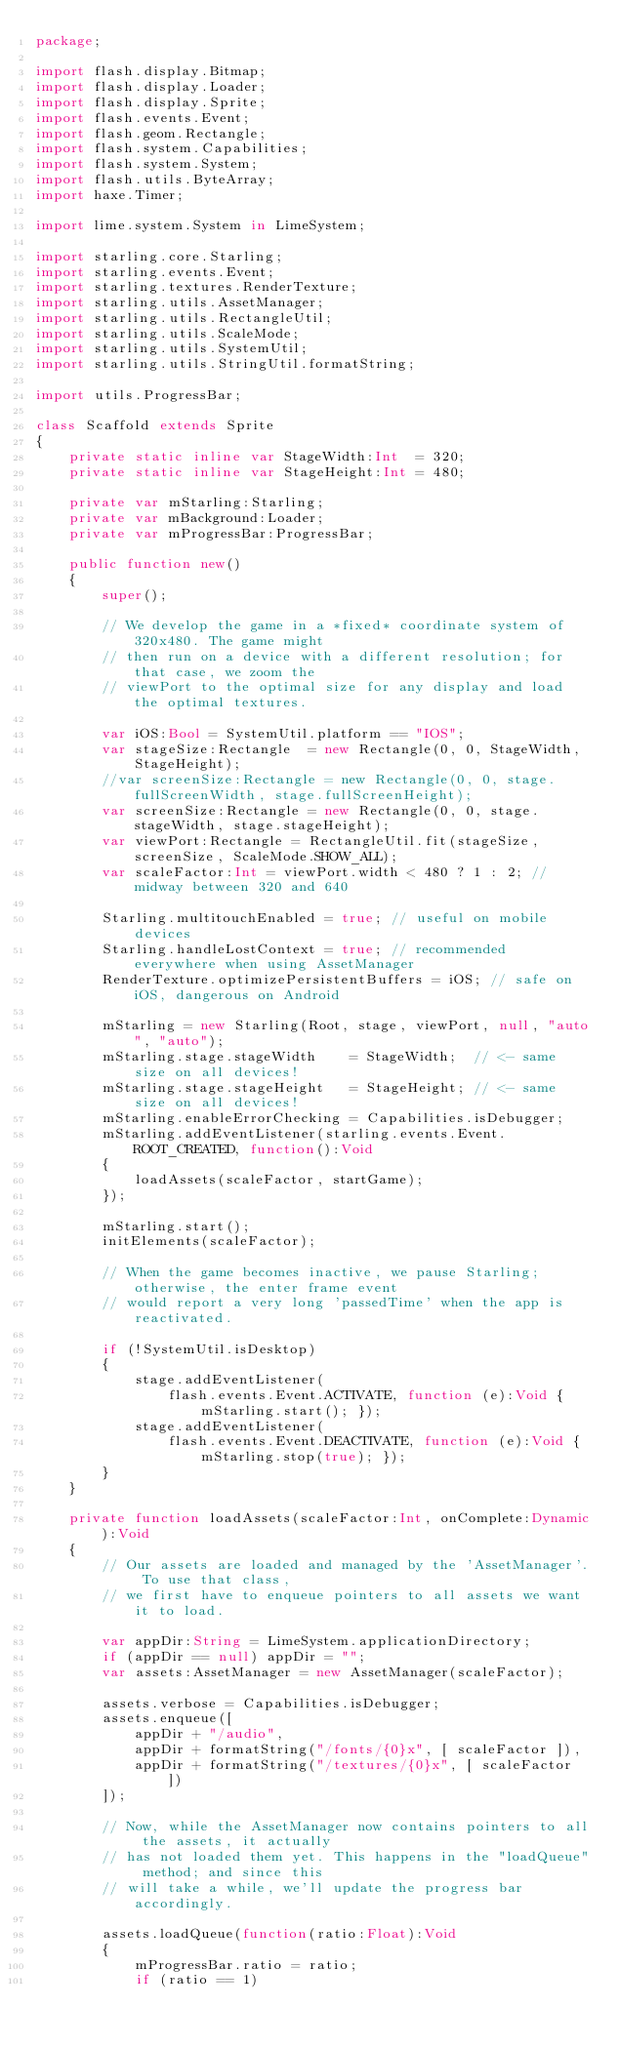Convert code to text. <code><loc_0><loc_0><loc_500><loc_500><_Haxe_>package;

import flash.display.Bitmap;
import flash.display.Loader;
import flash.display.Sprite;
import flash.events.Event;
import flash.geom.Rectangle;
import flash.system.Capabilities;
import flash.system.System;
import flash.utils.ByteArray;
import haxe.Timer;

import lime.system.System in LimeSystem;

import starling.core.Starling;
import starling.events.Event;
import starling.textures.RenderTexture;
import starling.utils.AssetManager;
import starling.utils.RectangleUtil;
import starling.utils.ScaleMode;
import starling.utils.SystemUtil;
import starling.utils.StringUtil.formatString;

import utils.ProgressBar;

class Scaffold extends Sprite
{
    private static inline var StageWidth:Int  = 320;
    private static inline var StageHeight:Int = 480;

    private var mStarling:Starling;
    private var mBackground:Loader;
    private var mProgressBar:ProgressBar;

    public function new()
    {
        super();

        // We develop the game in a *fixed* coordinate system of 320x480. The game might
        // then run on a device with a different resolution; for that case, we zoom the
        // viewPort to the optimal size for any display and load the optimal textures.

        var iOS:Bool = SystemUtil.platform == "IOS";
        var stageSize:Rectangle  = new Rectangle(0, 0, StageWidth, StageHeight);
        //var screenSize:Rectangle = new Rectangle(0, 0, stage.fullScreenWidth, stage.fullScreenHeight);
        var screenSize:Rectangle = new Rectangle(0, 0, stage.stageWidth, stage.stageHeight);
        var viewPort:Rectangle = RectangleUtil.fit(stageSize, screenSize, ScaleMode.SHOW_ALL);
        var scaleFactor:Int = viewPort.width < 480 ? 1 : 2; // midway between 320 and 640

        Starling.multitouchEnabled = true; // useful on mobile devices
        Starling.handleLostContext = true; // recommended everywhere when using AssetManager
        RenderTexture.optimizePersistentBuffers = iOS; // safe on iOS, dangerous on Android

        mStarling = new Starling(Root, stage, viewPort, null, "auto", "auto");
        mStarling.stage.stageWidth    = StageWidth;  // <- same size on all devices!
        mStarling.stage.stageHeight   = StageHeight; // <- same size on all devices!
        mStarling.enableErrorChecking = Capabilities.isDebugger;
        mStarling.addEventListener(starling.events.Event.ROOT_CREATED, function():Void
        {
            loadAssets(scaleFactor, startGame);
        });

        mStarling.start();
        initElements(scaleFactor);

        // When the game becomes inactive, we pause Starling; otherwise, the enter frame event
        // would report a very long 'passedTime' when the app is reactivated.

        if (!SystemUtil.isDesktop)
        {
            stage.addEventListener(
                flash.events.Event.ACTIVATE, function (e):Void { mStarling.start(); });
            stage.addEventListener(
                flash.events.Event.DEACTIVATE, function (e):Void { mStarling.stop(true); });
        }
    }

    private function loadAssets(scaleFactor:Int, onComplete:Dynamic):Void
    {
        // Our assets are loaded and managed by the 'AssetManager'. To use that class,
        // we first have to enqueue pointers to all assets we want it to load.

        var appDir:String = LimeSystem.applicationDirectory;
        if (appDir == null) appDir = "";
        var assets:AssetManager = new AssetManager(scaleFactor);

        assets.verbose = Capabilities.isDebugger;
        assets.enqueue([
            appDir + "/audio",
            appDir + formatString("/fonts/{0}x", [ scaleFactor ]),
            appDir + formatString("/textures/{0}x", [ scaleFactor ])
        ]);

        // Now, while the AssetManager now contains pointers to all the assets, it actually
        // has not loaded them yet. This happens in the "loadQueue" method; and since this
        // will take a while, we'll update the progress bar accordingly.

        assets.loadQueue(function(ratio:Float):Void
        {
            mProgressBar.ratio = ratio;
            if (ratio == 1)</code> 